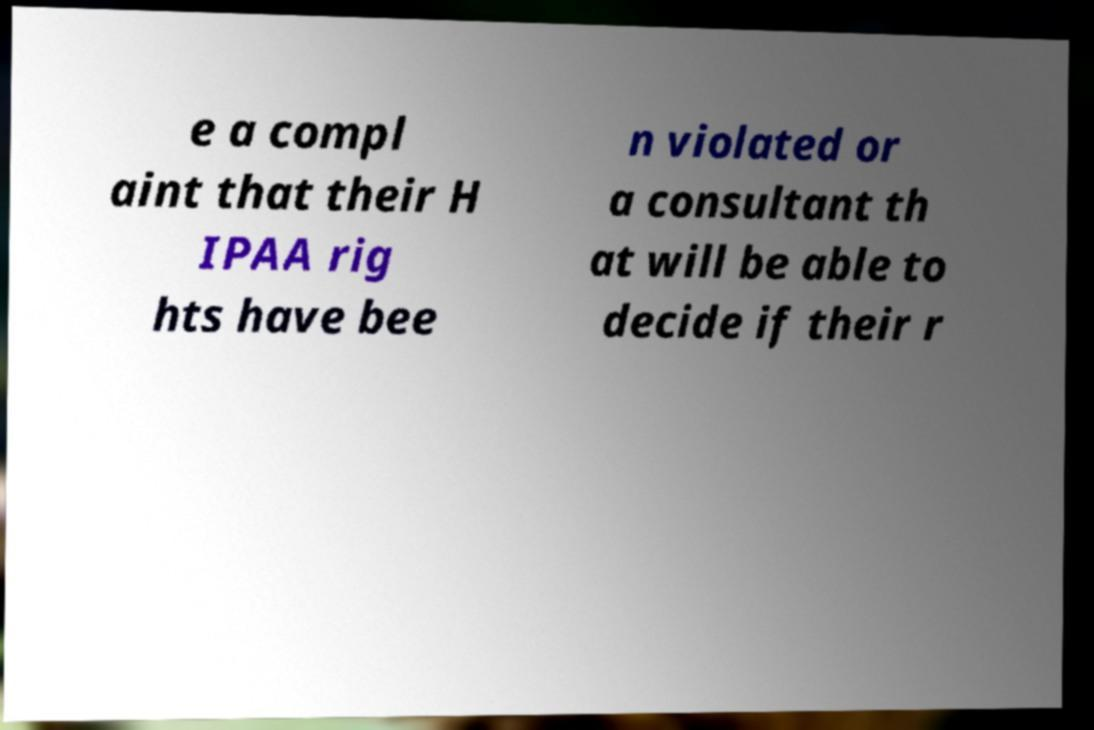Please read and relay the text visible in this image. What does it say? e a compl aint that their H IPAA rig hts have bee n violated or a consultant th at will be able to decide if their r 